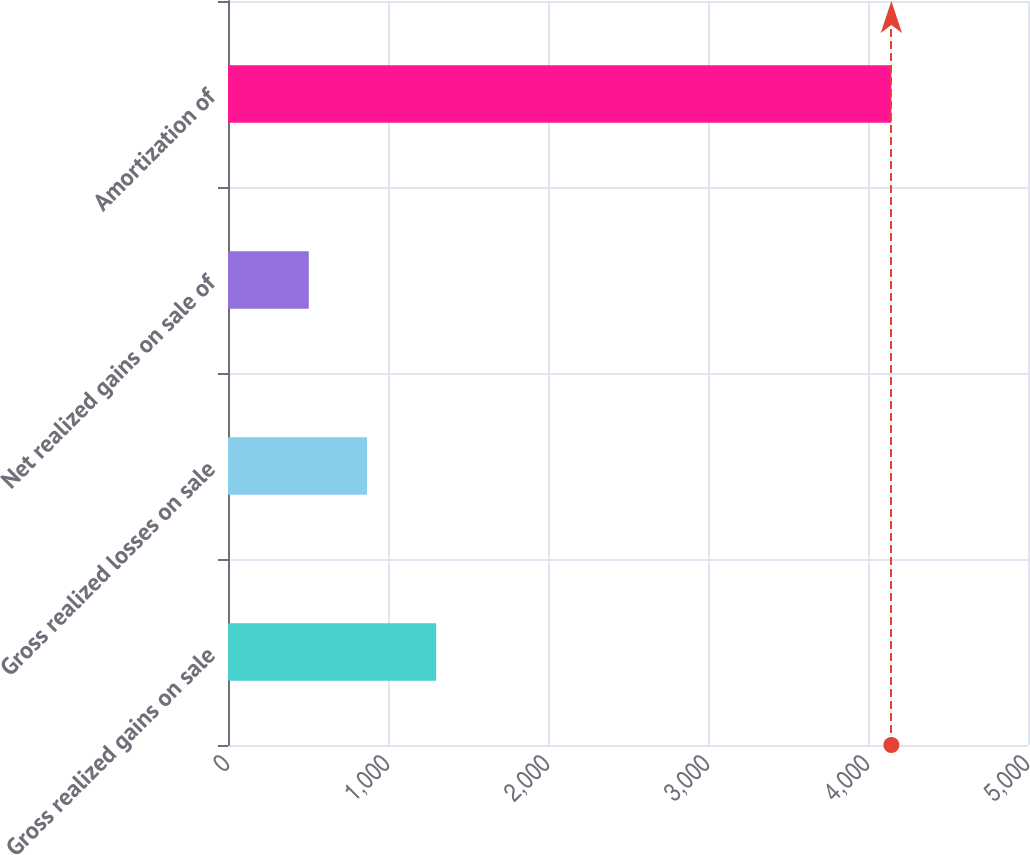<chart> <loc_0><loc_0><loc_500><loc_500><bar_chart><fcel>Gross realized gains on sale<fcel>Gross realized losses on sale<fcel>Net realized gains on sale of<fcel>Amortization of<nl><fcel>1301<fcel>869.1<fcel>505<fcel>4146<nl></chart> 